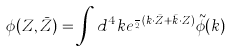Convert formula to latex. <formula><loc_0><loc_0><loc_500><loc_500>\phi ( Z , \bar { Z } ) = \int d ^ { 4 } k e ^ { \frac { i } { 2 } ( k \cdot \bar { Z } + \bar { k } \cdot Z ) } \tilde { \phi } ( k )</formula> 